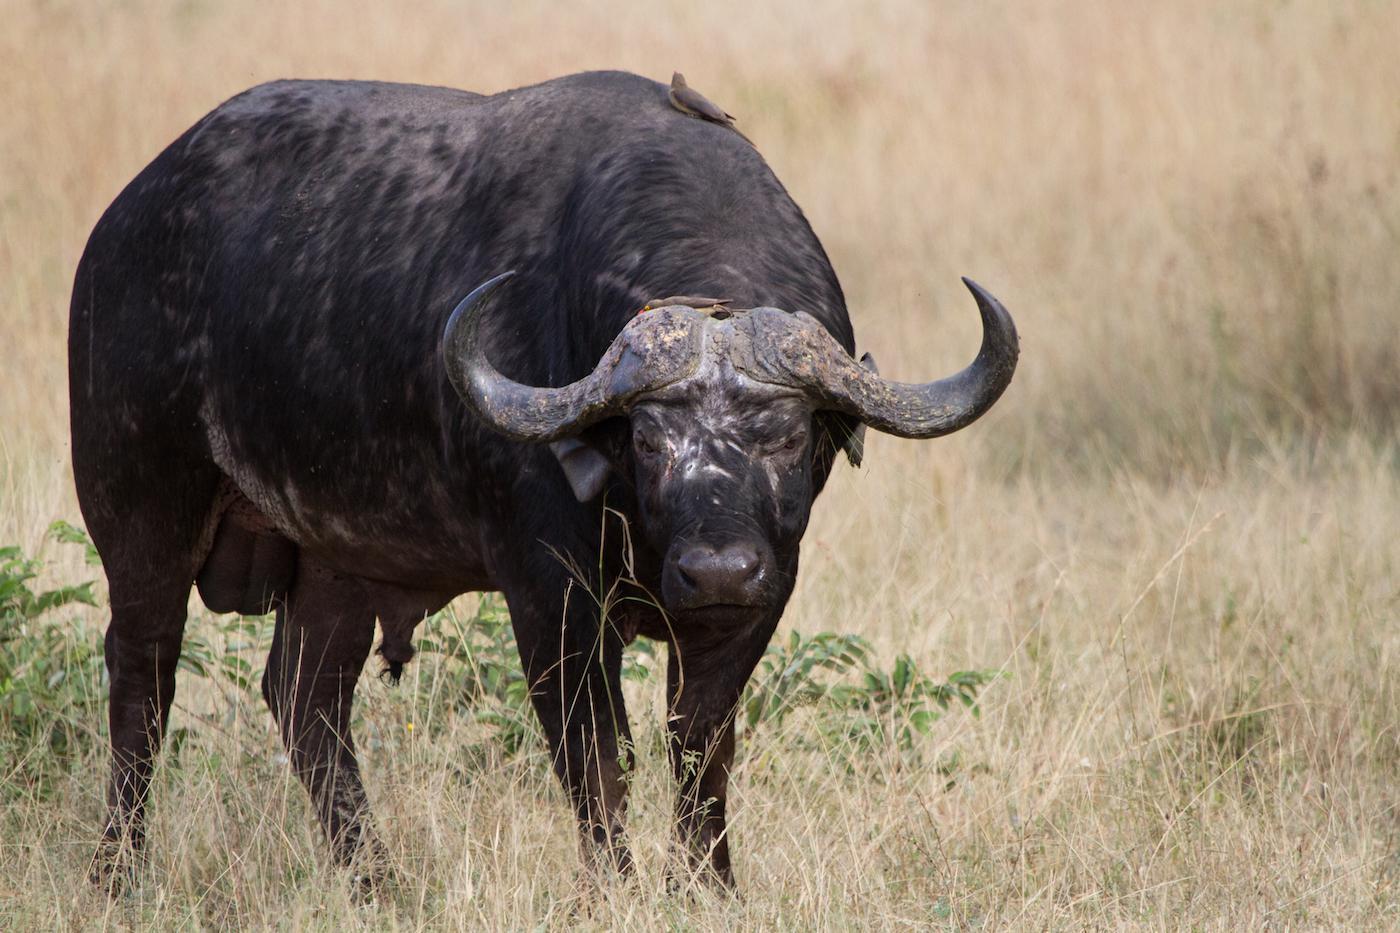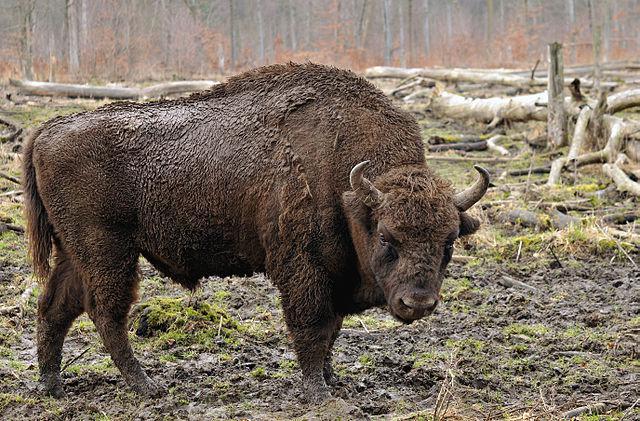The first image is the image on the left, the second image is the image on the right. Examine the images to the left and right. Is the description "An action scene with a water buffalo features a maned lion." accurate? Answer yes or no. No. The first image is the image on the left, the second image is the image on the right. Examine the images to the left and right. Is the description "One image is an action scene involving at least one water buffalo and one lion, while the other image is a single water buffalo facing forward." accurate? Answer yes or no. No. 